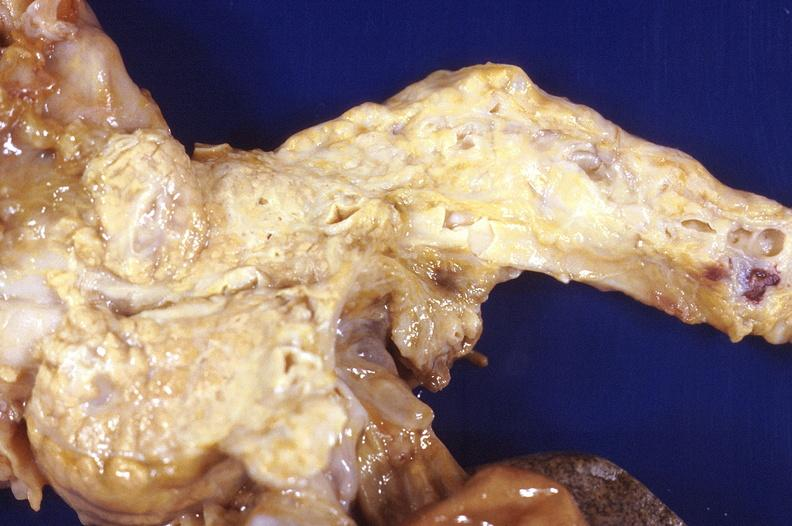does this image show prostatic hyperplasia?
Answer the question using a single word or phrase. Yes 